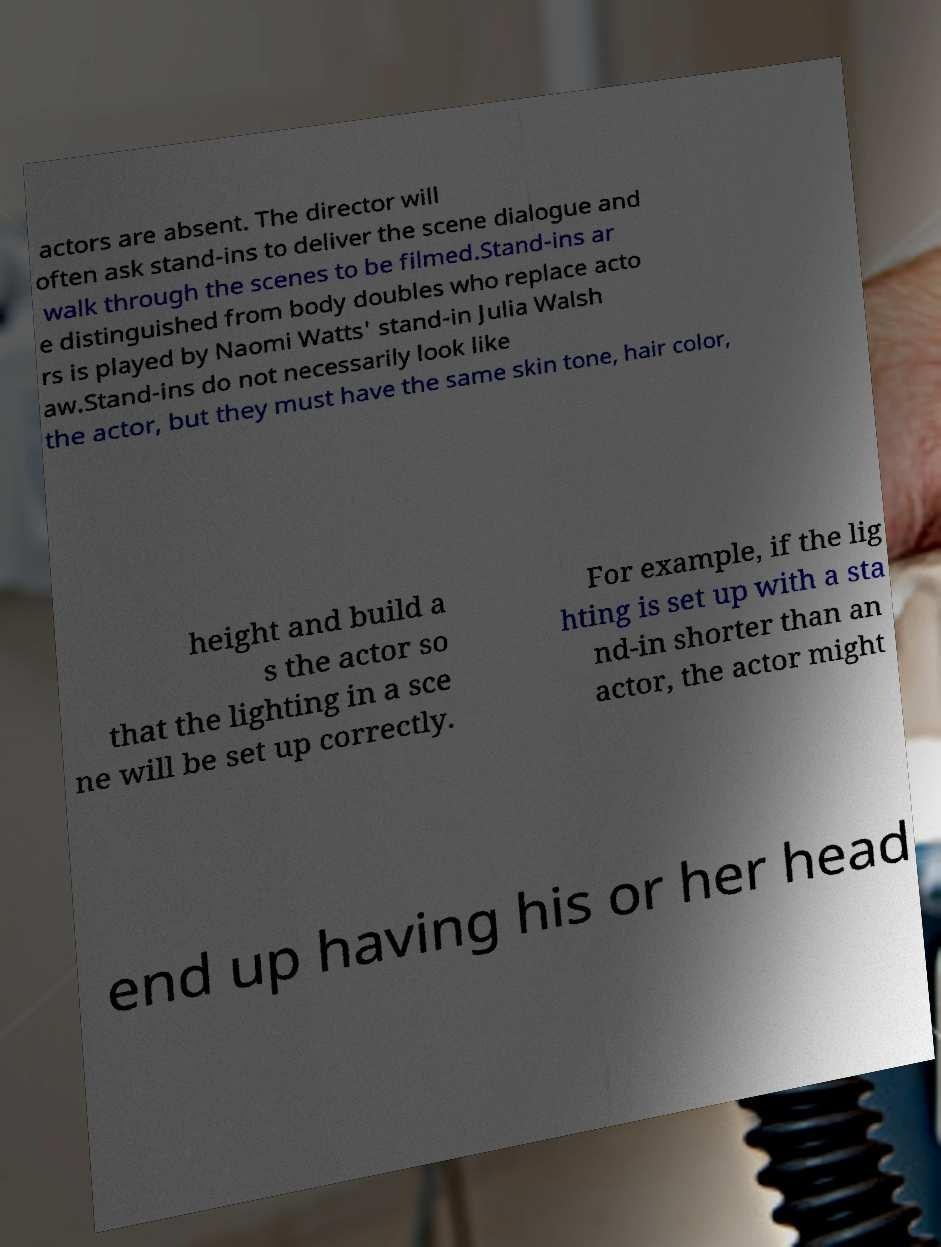For documentation purposes, I need the text within this image transcribed. Could you provide that? actors are absent. The director will often ask stand-ins to deliver the scene dialogue and walk through the scenes to be filmed.Stand-ins ar e distinguished from body doubles who replace acto rs is played by Naomi Watts' stand-in Julia Walsh aw.Stand-ins do not necessarily look like the actor, but they must have the same skin tone, hair color, height and build a s the actor so that the lighting in a sce ne will be set up correctly. For example, if the lig hting is set up with a sta nd-in shorter than an actor, the actor might end up having his or her head 